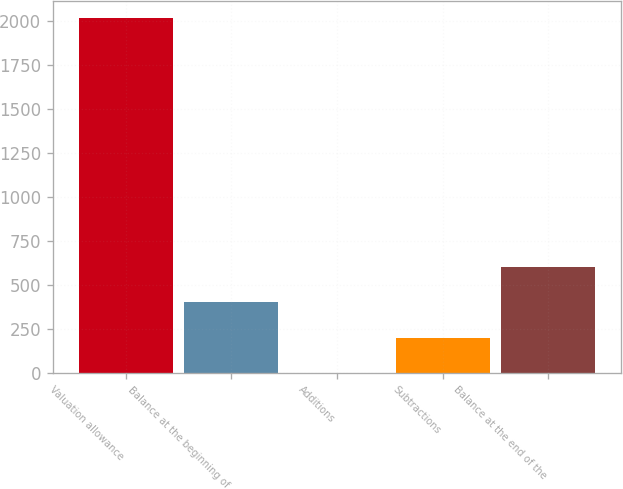Convert chart to OTSL. <chart><loc_0><loc_0><loc_500><loc_500><bar_chart><fcel>Valuation allowance<fcel>Balance at the beginning of<fcel>Additions<fcel>Subtractions<fcel>Balance at the end of the<nl><fcel>2013<fcel>402.93<fcel>0.41<fcel>201.67<fcel>604.19<nl></chart> 